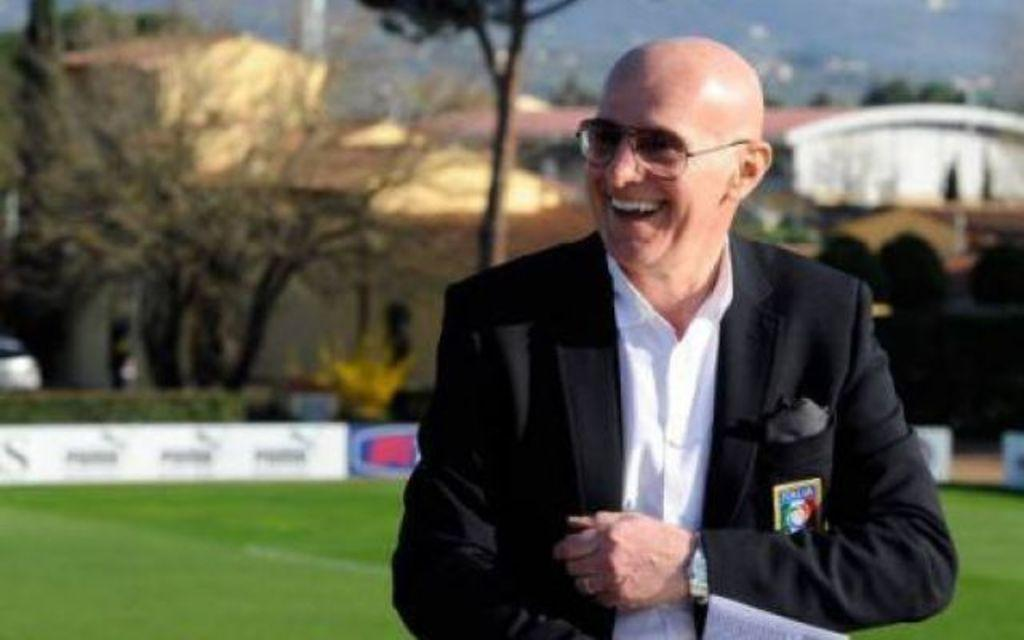Who is present in the image? There is a man in the image. What is the man's expression? The man is smiling. What can be seen in the background of the image? There are hoardings, trees, plants, grass, buildings, objects, and the sky visible in the background of the image. What channel is the man watching on the television in the image? There is no television present in the image, so it is not possible to determine what channel the man might be watching. 